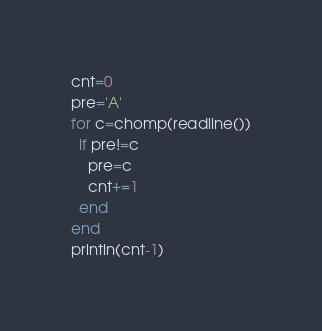<code> <loc_0><loc_0><loc_500><loc_500><_Julia_>cnt=0
pre='A'
for c=chomp(readline())
  if pre!=c
    pre=c
    cnt+=1
  end
end
println(cnt-1)</code> 